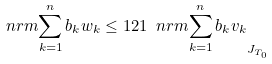<formula> <loc_0><loc_0><loc_500><loc_500>\ n r m { \sum _ { k = 1 } ^ { n } b _ { k } w _ { k } } \leq 1 2 1 \ n r m { \sum _ { k = 1 } ^ { n } b _ { k } v _ { k } } _ { J _ { T _ { 0 } } }</formula> 